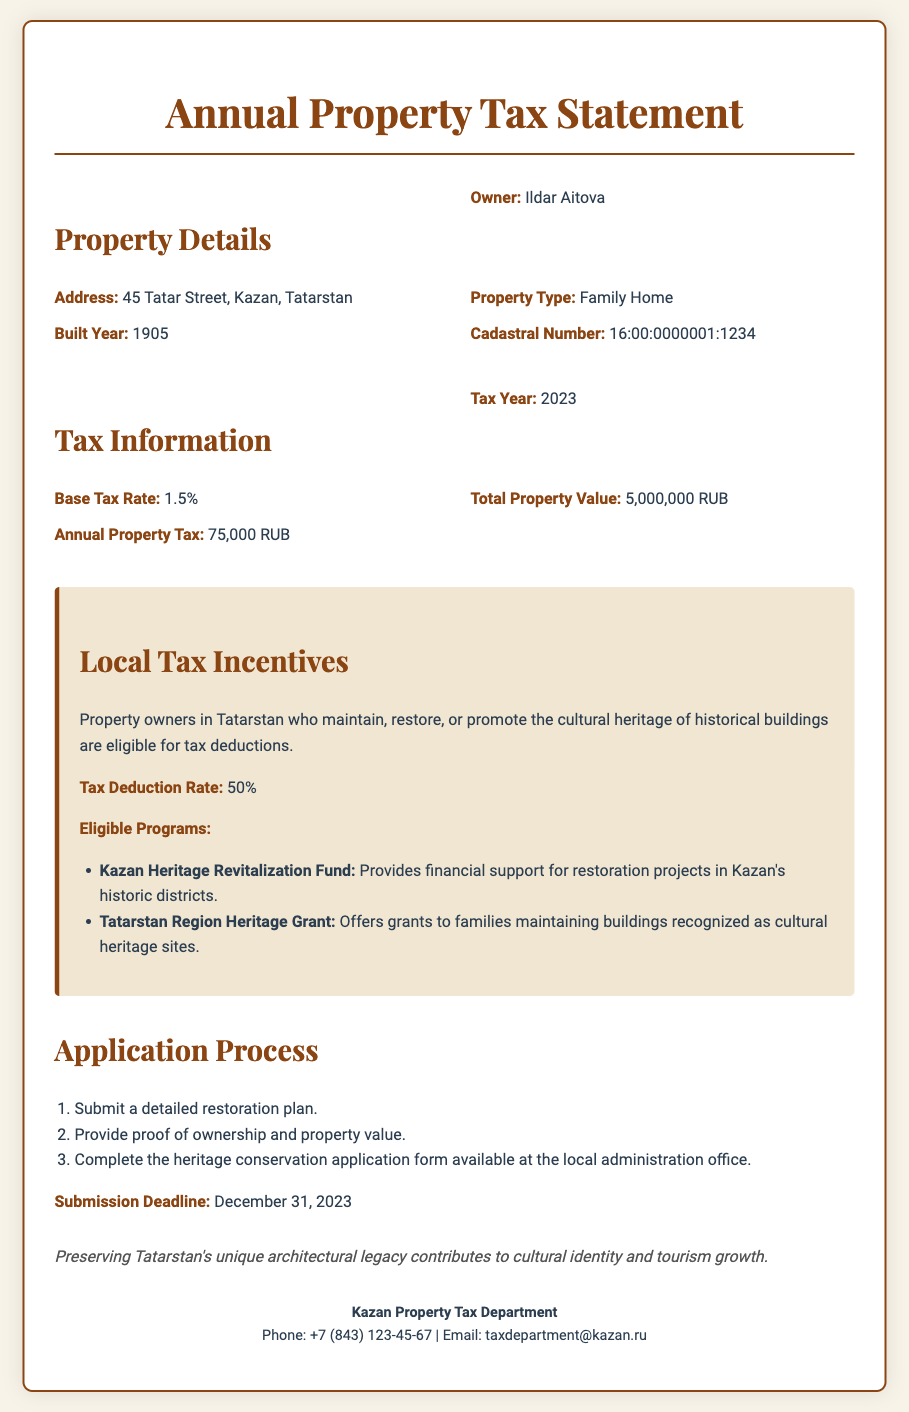what is the property owner's name? The property owner is identified in the document as Ildar Aitova.
Answer: Ildar Aitova what is the address of the property? The document states the property address as 45 Tatar Street, Kazan, Tatarstan.
Answer: 45 Tatar Street, Kazan, Tatarstan what year was the property built? The built year of the property is explicitly mentioned in the document as 1905.
Answer: 1905 what is the annual property tax amount? The total annual property tax calculated in the document is specified as 75,000 RUB.
Answer: 75,000 RUB what is the tax deduction rate for heritage conservation? The document indicates that the tax deduction rate for heritage conservation is 50%.
Answer: 50% what must be submitted first in the application process? The first step in the application process is to submit a detailed restoration plan.
Answer: Submit a detailed restoration plan which fund supports restoration projects in Kazan's historic districts? The Kazan Heritage Revitalization Fund is designed to provide support for projects in the historic districts.
Answer: Kazan Heritage Revitalization Fund what is the submission deadline for the application? The document specifies the submission deadline as December 31, 2023.
Answer: December 31, 2023 why is preserving Tatarstan's architectural legacy important? The document notes that preserving this legacy contributes to cultural identity and tourism growth.
Answer: Cultural identity and tourism growth 